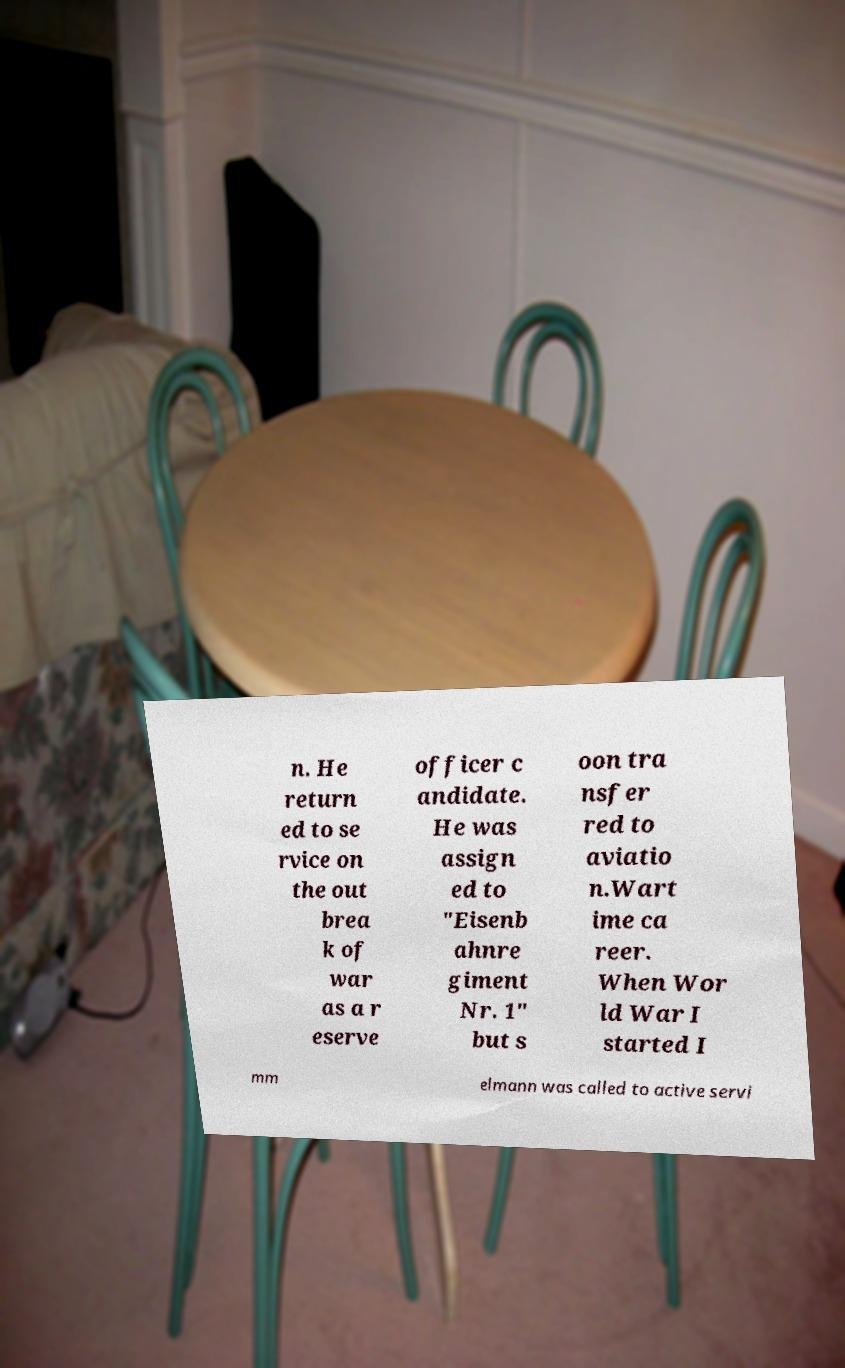Can you read and provide the text displayed in the image?This photo seems to have some interesting text. Can you extract and type it out for me? n. He return ed to se rvice on the out brea k of war as a r eserve officer c andidate. He was assign ed to "Eisenb ahnre giment Nr. 1" but s oon tra nsfer red to aviatio n.Wart ime ca reer. When Wor ld War I started I mm elmann was called to active servi 